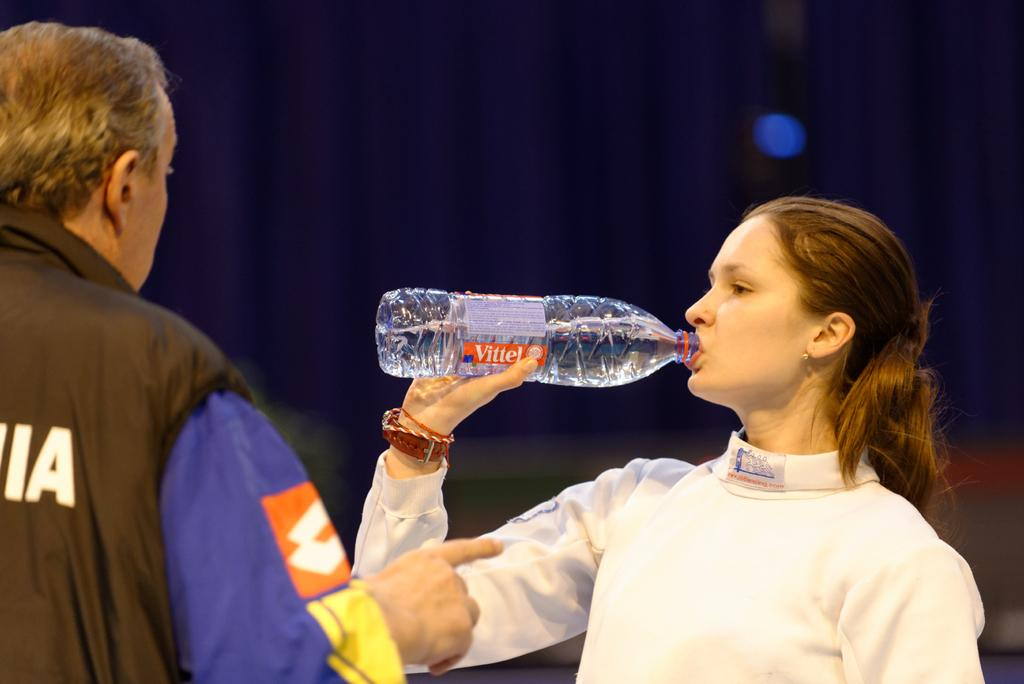Provide a one-sentence caption for the provided image. A man and a women in a room facing each other where the women is drinking a bottle of Vittel. 